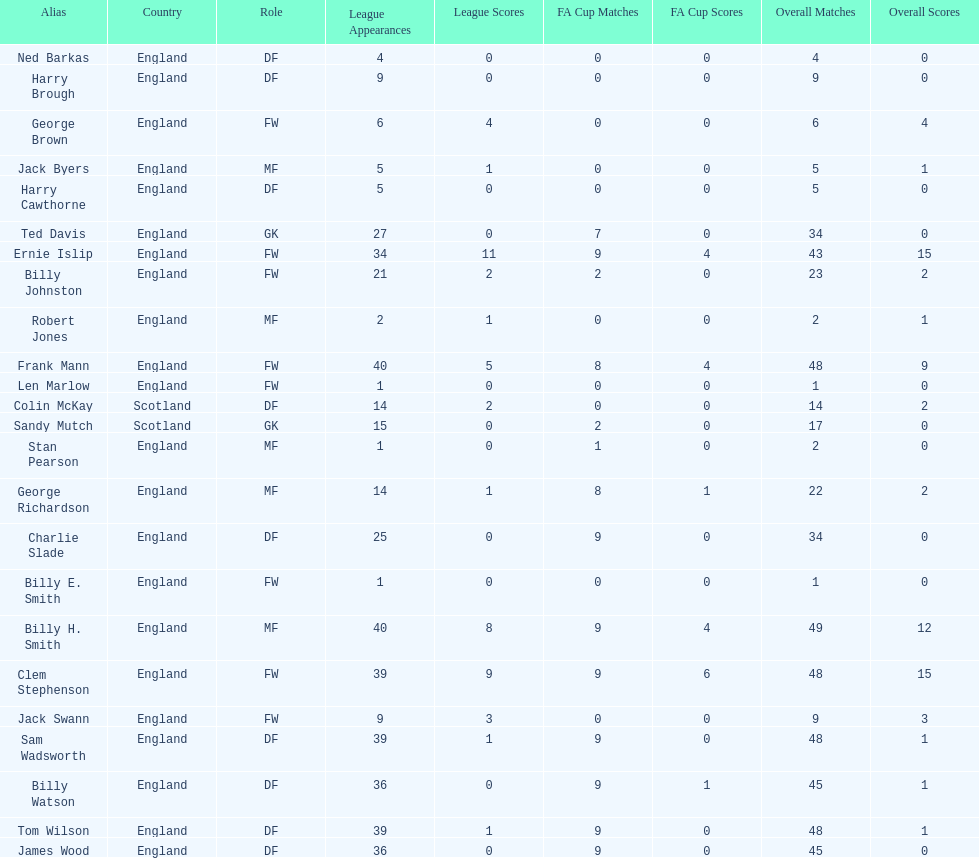The smallest number of overall occurrences 1. 